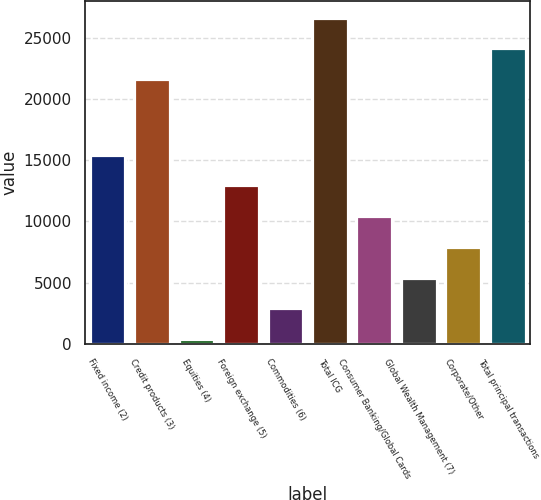Convert chart. <chart><loc_0><loc_0><loc_500><loc_500><bar_chart><fcel>Fixed income (2)<fcel>Credit products (3)<fcel>Equities (4)<fcel>Foreign exchange (5)<fcel>Commodities (6)<fcel>Total ICG<fcel>Consumer Banking/Global Cards<fcel>Global Wealth Management (7)<fcel>Corporate/Other<fcel>Total principal transactions<nl><fcel>15445.6<fcel>21614<fcel>394<fcel>12937<fcel>2902.6<fcel>26631.2<fcel>10428.4<fcel>5411.2<fcel>7919.8<fcel>24122.6<nl></chart> 